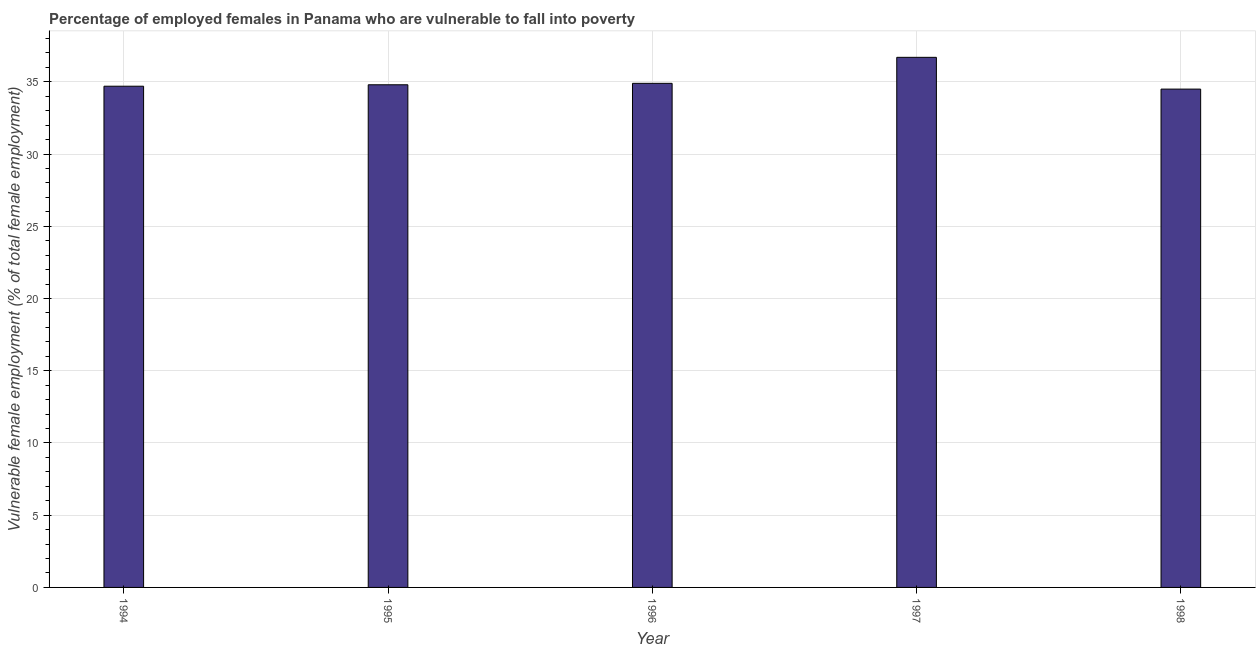What is the title of the graph?
Your answer should be very brief. Percentage of employed females in Panama who are vulnerable to fall into poverty. What is the label or title of the X-axis?
Ensure brevity in your answer.  Year. What is the label or title of the Y-axis?
Give a very brief answer. Vulnerable female employment (% of total female employment). What is the percentage of employed females who are vulnerable to fall into poverty in 1994?
Ensure brevity in your answer.  34.7. Across all years, what is the maximum percentage of employed females who are vulnerable to fall into poverty?
Make the answer very short. 36.7. Across all years, what is the minimum percentage of employed females who are vulnerable to fall into poverty?
Offer a terse response. 34.5. What is the sum of the percentage of employed females who are vulnerable to fall into poverty?
Keep it short and to the point. 175.6. What is the difference between the percentage of employed females who are vulnerable to fall into poverty in 1995 and 1996?
Offer a very short reply. -0.1. What is the average percentage of employed females who are vulnerable to fall into poverty per year?
Offer a terse response. 35.12. What is the median percentage of employed females who are vulnerable to fall into poverty?
Provide a succinct answer. 34.8. Do a majority of the years between 1995 and 1994 (inclusive) have percentage of employed females who are vulnerable to fall into poverty greater than 19 %?
Your answer should be very brief. No. Is the difference between the percentage of employed females who are vulnerable to fall into poverty in 1995 and 1998 greater than the difference between any two years?
Provide a short and direct response. No. What is the difference between the highest and the second highest percentage of employed females who are vulnerable to fall into poverty?
Your answer should be compact. 1.8. Is the sum of the percentage of employed females who are vulnerable to fall into poverty in 1996 and 1998 greater than the maximum percentage of employed females who are vulnerable to fall into poverty across all years?
Your answer should be compact. Yes. In how many years, is the percentage of employed females who are vulnerable to fall into poverty greater than the average percentage of employed females who are vulnerable to fall into poverty taken over all years?
Make the answer very short. 1. How many bars are there?
Your response must be concise. 5. What is the difference between two consecutive major ticks on the Y-axis?
Make the answer very short. 5. Are the values on the major ticks of Y-axis written in scientific E-notation?
Your answer should be very brief. No. What is the Vulnerable female employment (% of total female employment) of 1994?
Give a very brief answer. 34.7. What is the Vulnerable female employment (% of total female employment) in 1995?
Provide a succinct answer. 34.8. What is the Vulnerable female employment (% of total female employment) of 1996?
Make the answer very short. 34.9. What is the Vulnerable female employment (% of total female employment) of 1997?
Your response must be concise. 36.7. What is the Vulnerable female employment (% of total female employment) of 1998?
Keep it short and to the point. 34.5. What is the difference between the Vulnerable female employment (% of total female employment) in 1994 and 1996?
Make the answer very short. -0.2. What is the difference between the Vulnerable female employment (% of total female employment) in 1994 and 1998?
Your answer should be compact. 0.2. What is the difference between the Vulnerable female employment (% of total female employment) in 1995 and 1996?
Give a very brief answer. -0.1. What is the ratio of the Vulnerable female employment (% of total female employment) in 1994 to that in 1995?
Provide a short and direct response. 1. What is the ratio of the Vulnerable female employment (% of total female employment) in 1994 to that in 1997?
Provide a succinct answer. 0.95. What is the ratio of the Vulnerable female employment (% of total female employment) in 1995 to that in 1997?
Your answer should be very brief. 0.95. What is the ratio of the Vulnerable female employment (% of total female employment) in 1995 to that in 1998?
Make the answer very short. 1.01. What is the ratio of the Vulnerable female employment (% of total female employment) in 1996 to that in 1997?
Provide a short and direct response. 0.95. What is the ratio of the Vulnerable female employment (% of total female employment) in 1997 to that in 1998?
Provide a succinct answer. 1.06. 